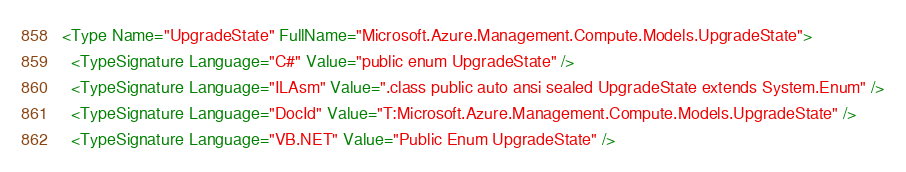Convert code to text. <code><loc_0><loc_0><loc_500><loc_500><_XML_><Type Name="UpgradeState" FullName="Microsoft.Azure.Management.Compute.Models.UpgradeState">
  <TypeSignature Language="C#" Value="public enum UpgradeState" />
  <TypeSignature Language="ILAsm" Value=".class public auto ansi sealed UpgradeState extends System.Enum" />
  <TypeSignature Language="DocId" Value="T:Microsoft.Azure.Management.Compute.Models.UpgradeState" />
  <TypeSignature Language="VB.NET" Value="Public Enum UpgradeState" /></code> 